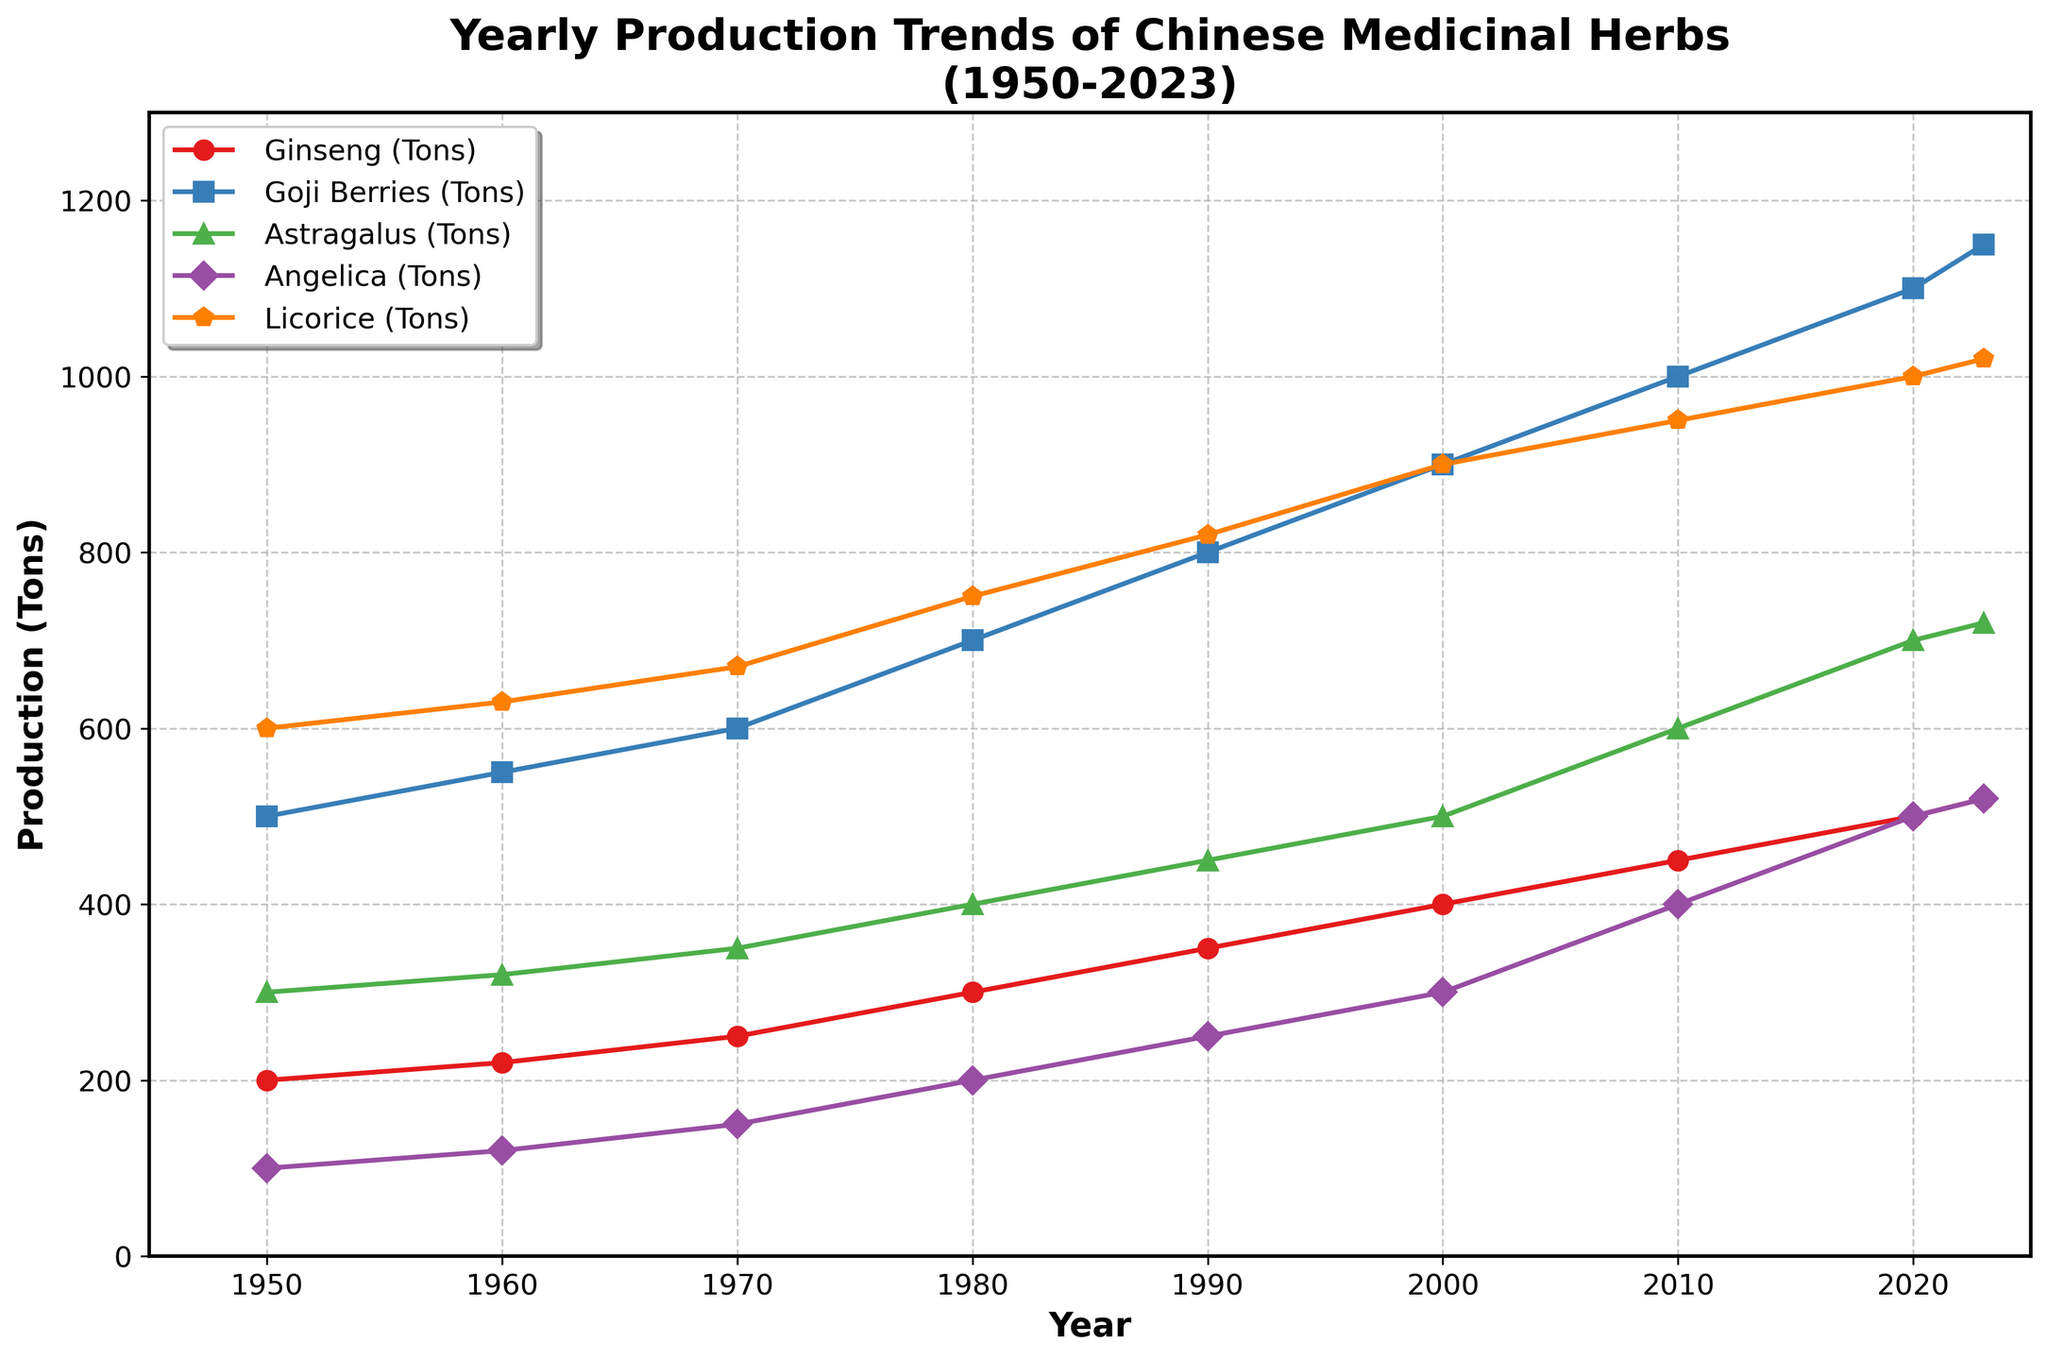Which medicinal herb had the highest production in 1950? From the figure, each herb has its own trend line, and we observe the production of each herb at the year 1950. Licorice had the highest production in 1950.
Answer: Licorice What is the overall trend in ginseng production from 1950 to 2023? Observing the ginseng trend line from 1950 to 2023, it shows a consistent upward trend from 200 tons in 1950 to 520 tons in 2023.
Answer: Upward trend How much did goji berry production increase between 1960 and 2020? By looking at the goji berry trend line, the production in 1960 was 550 tons while in 2020 it was 1100 tons. The increase is 1100 - 550 = 550 tons.
Answer: 550 tons Which herb experienced the largest production increase between 1980 and 2000? Comparing the increases from 1980 to 2000 for each herb: Ginseng (400-300=100), Goji Berries (900-700=200), Astragalus (500-400=100), Angelica (300-200=100), Licorice (900-750=150), Goji Berries had the largest increase.
Answer: Goji Berries What was the production difference between the highest and lowest produced herbs in 2010? Analyzing the production in 2010: Ginseng (450), Goji Berries (1000), Astragalus (600), Angelica (400), and Licorice (950). The highest is 1000 tons (Goji Berries) and the lowest is 400 tons (Angelica), yielding a difference of 1000 - 400 = 600 tons.
Answer: 600 tons Compare the production trends of Angelica and Astragalus. Observing both trend lines, Angelica started at 100 tons in 1950, rising to 520 tons by 2023, while Astragalus rose from 300 tons in 1950 to 720 tons in 2023. Both show an increasing trend but Astragalus had a higher overall growth.
Answer: Both increasing, Astragalus grew more How does the production of licorice in 2023 compare to its production in 1990? Licorice production in 1990 was 820 tons, while in 2023 it was 1020 tons. This shows an increase of 1020 - 820 = 200 tons.
Answer: Increased by 200 tons On average, how much did the annual production of ginseng increase per decade from 1950 to 2020? Ginseng production increased from 200 tons in 1950 to 500 tons in 2020, a total increase of 300 tons over 70 years (7 decades). The average annual increase per decade is 300 / 7 ≈ 42.86 tons.
Answer: About 42.86 tons What is the rate of change in the production of Angelica from 2000 to 2023? Angelica's production in 2000 was 300 tons, and in 2023 it was 520 tons. The change is 520 - 300 = 220 tons over 23 years, giving a rate of change of 220 / 23 ≈ 9.57 tons per year.
Answer: About 9.57 tons per year 